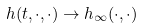Convert formula to latex. <formula><loc_0><loc_0><loc_500><loc_500>h ( t , \cdot , \cdot ) \to h _ { \infty } ( \cdot , \cdot )</formula> 